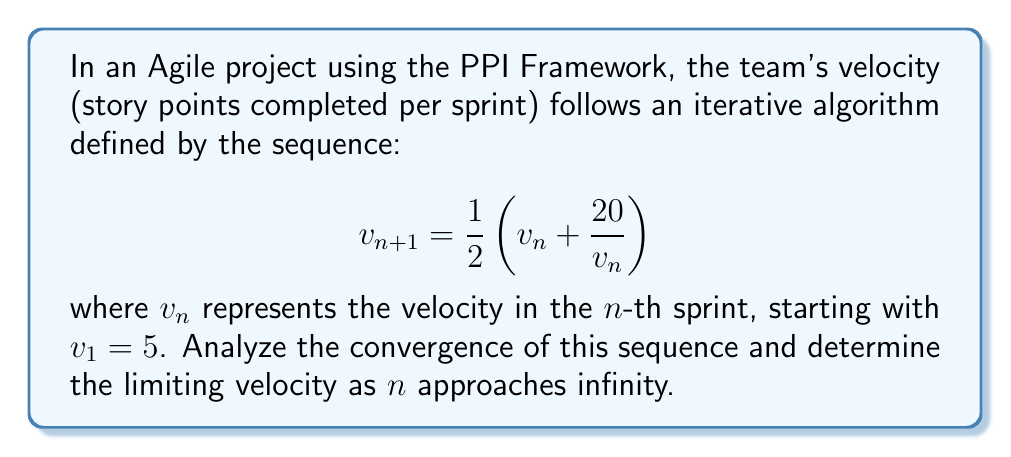Help me with this question. To analyze the convergence of this iterative algorithm, we'll follow these steps:

1) First, let's recognize this as a fixed-point iteration. The sequence will converge if it has a fixed point and if the iteration function is contractive near that fixed point.

2) To find the fixed point, we solve the equation:
   $$v = \frac{1}{2}(v + \frac{20}{v})$$

3) Multiplying both sides by $2v$:
   $$2v^2 = v^2 + 20$$
   $$v^2 = 20$$
   $$v = \sqrt{20} \approx 4.47$$

4) Now, we need to check if the iteration function is contractive near this fixed point. Let $f(v) = \frac{1}{2}(v + \frac{20}{v})$. We compute its derivative:

   $$f'(v) = \frac{1}{2}(1 - \frac{20}{v^2})$$

5) At the fixed point $v = \sqrt{20}$, we have:
   $$f'(\sqrt{20}) = \frac{1}{2}(1 - \frac{20}{20}) = 0$$

6) Since $|f'(\sqrt{20})| < 1$, the iteration is contractive near the fixed point, ensuring local convergence.

7) To verify global convergence, we can show that $f(v)$ always lies between $v$ and $\sqrt{20}$ for $v > 0$:

   If $v < \sqrt{20}$, then $\frac{20}{v} > \sqrt{20}$, so $v < f(v) < \sqrt{20}$
   If $v > \sqrt{20}$, then $\frac{20}{v} < \sqrt{20}$, so $\sqrt{20} < f(v) < v$

   This ensures that the sequence always moves towards $\sqrt{20}$, regardless of the starting point.

Therefore, the sequence converges to $\sqrt{20}$ as $n$ approaches infinity, representing the limiting velocity of the Agile team using the PPI Framework.
Answer: $\sqrt{20}$ 